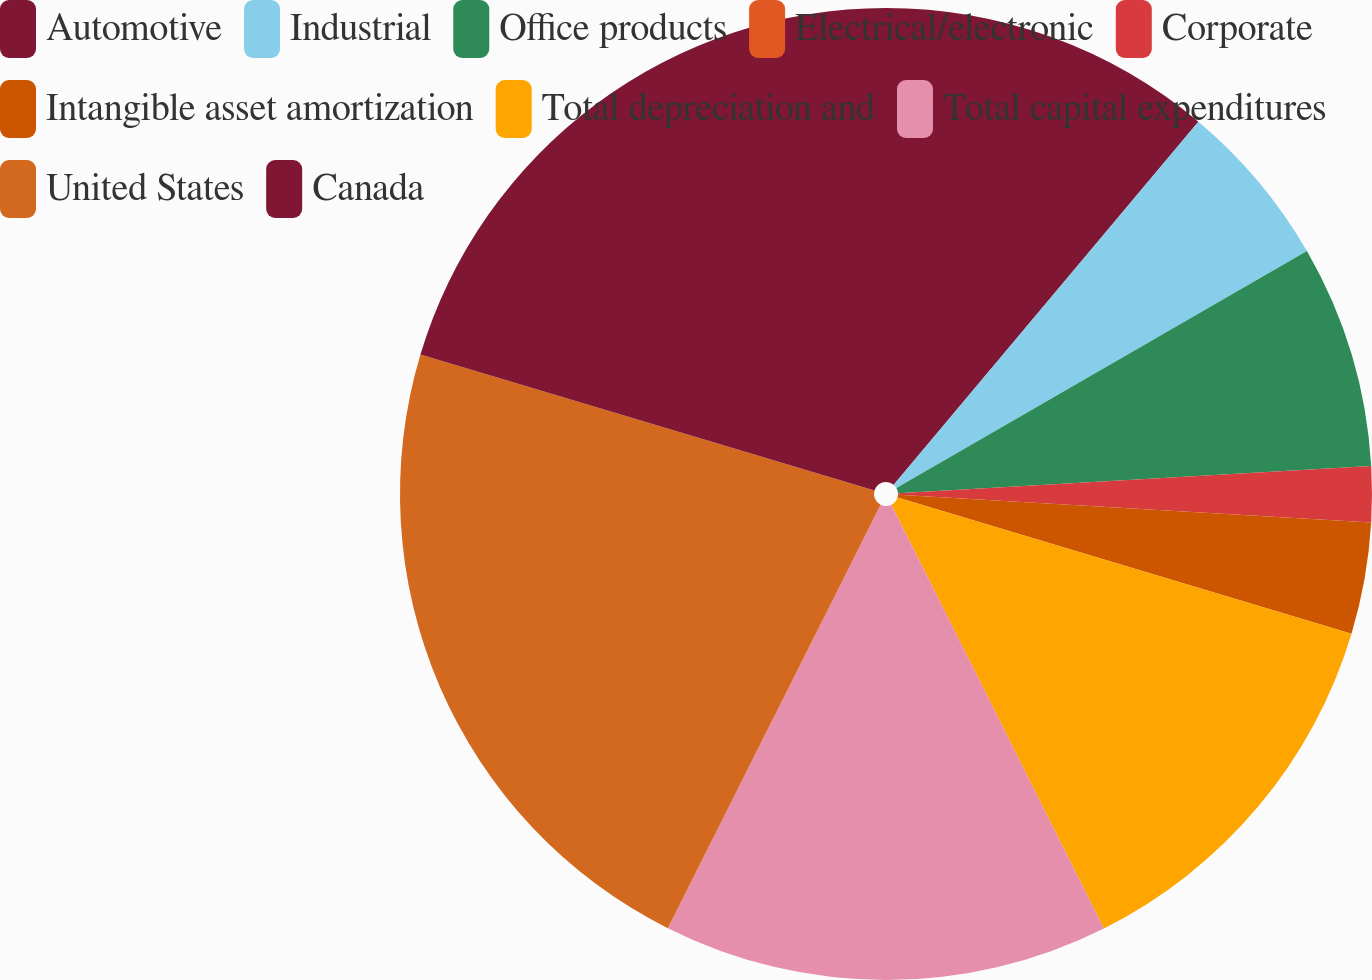Convert chart to OTSL. <chart><loc_0><loc_0><loc_500><loc_500><pie_chart><fcel>Automotive<fcel>Industrial<fcel>Office products<fcel>Electrical/electronic<fcel>Corporate<fcel>Intangible asset amortization<fcel>Total depreciation and<fcel>Total capital expenditures<fcel>United States<fcel>Canada<nl><fcel>11.11%<fcel>5.56%<fcel>7.41%<fcel>0.0%<fcel>1.85%<fcel>3.71%<fcel>12.96%<fcel>14.81%<fcel>22.22%<fcel>20.37%<nl></chart> 